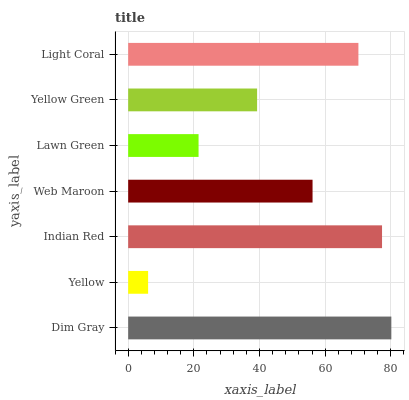Is Yellow the minimum?
Answer yes or no. Yes. Is Dim Gray the maximum?
Answer yes or no. Yes. Is Indian Red the minimum?
Answer yes or no. No. Is Indian Red the maximum?
Answer yes or no. No. Is Indian Red greater than Yellow?
Answer yes or no. Yes. Is Yellow less than Indian Red?
Answer yes or no. Yes. Is Yellow greater than Indian Red?
Answer yes or no. No. Is Indian Red less than Yellow?
Answer yes or no. No. Is Web Maroon the high median?
Answer yes or no. Yes. Is Web Maroon the low median?
Answer yes or no. Yes. Is Yellow the high median?
Answer yes or no. No. Is Yellow Green the low median?
Answer yes or no. No. 